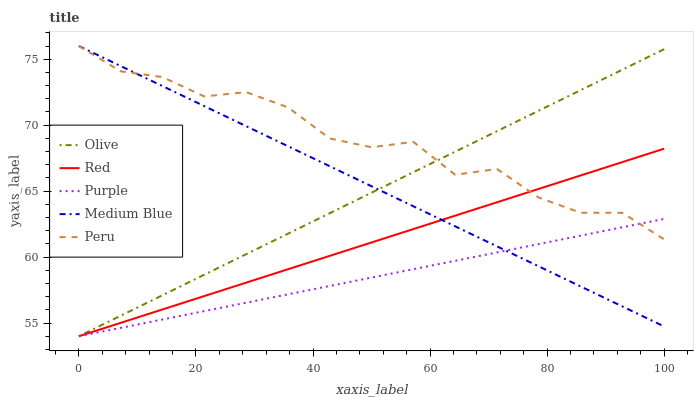Does Purple have the minimum area under the curve?
Answer yes or no. Yes. Does Peru have the maximum area under the curve?
Answer yes or no. Yes. Does Medium Blue have the minimum area under the curve?
Answer yes or no. No. Does Medium Blue have the maximum area under the curve?
Answer yes or no. No. Is Purple the smoothest?
Answer yes or no. Yes. Is Peru the roughest?
Answer yes or no. Yes. Is Medium Blue the smoothest?
Answer yes or no. No. Is Medium Blue the roughest?
Answer yes or no. No. Does Olive have the lowest value?
Answer yes or no. Yes. Does Medium Blue have the lowest value?
Answer yes or no. No. Does Peru have the highest value?
Answer yes or no. Yes. Does Purple have the highest value?
Answer yes or no. No. Does Peru intersect Olive?
Answer yes or no. Yes. Is Peru less than Olive?
Answer yes or no. No. Is Peru greater than Olive?
Answer yes or no. No. 